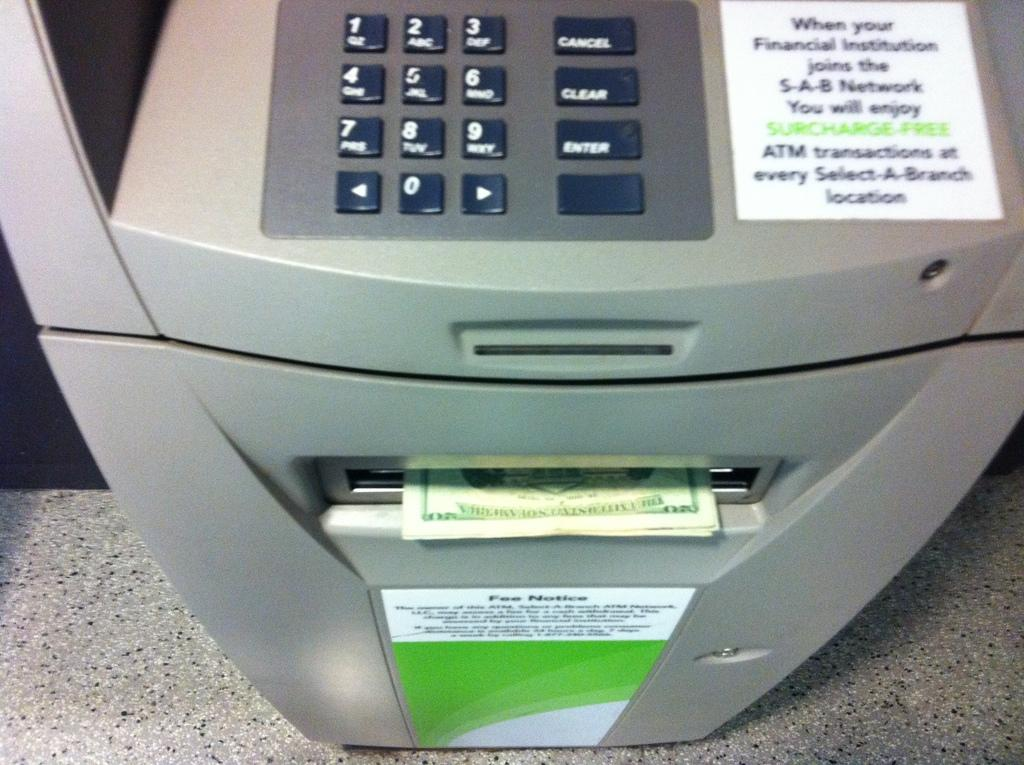Provide a one-sentence caption for the provided image. A surcharge-free ATM with a stack of 20 dollar bills coming out. 